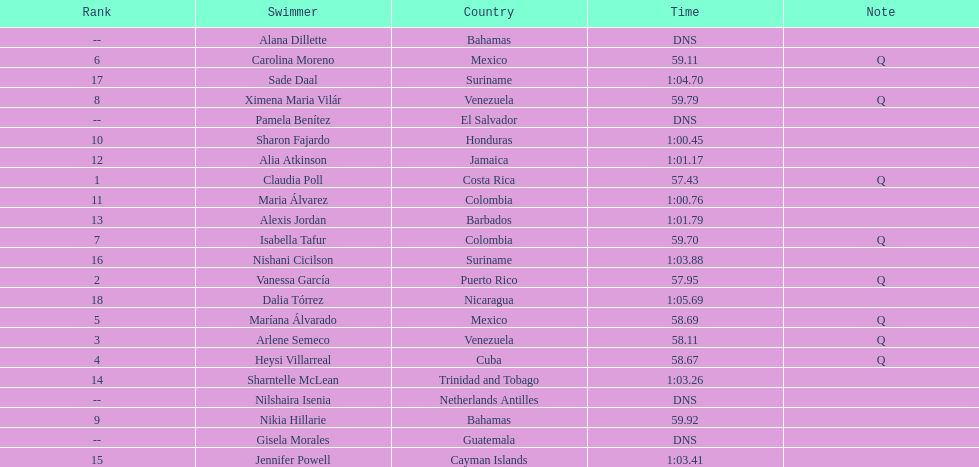Who finished after claudia poll? Vanessa García. 